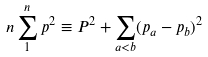Convert formula to latex. <formula><loc_0><loc_0><loc_500><loc_500>n \sum _ { 1 } ^ { n } p ^ { 2 } \equiv P ^ { 2 } + \sum _ { a < b } ( p _ { a } - p _ { b } ) ^ { 2 }</formula> 